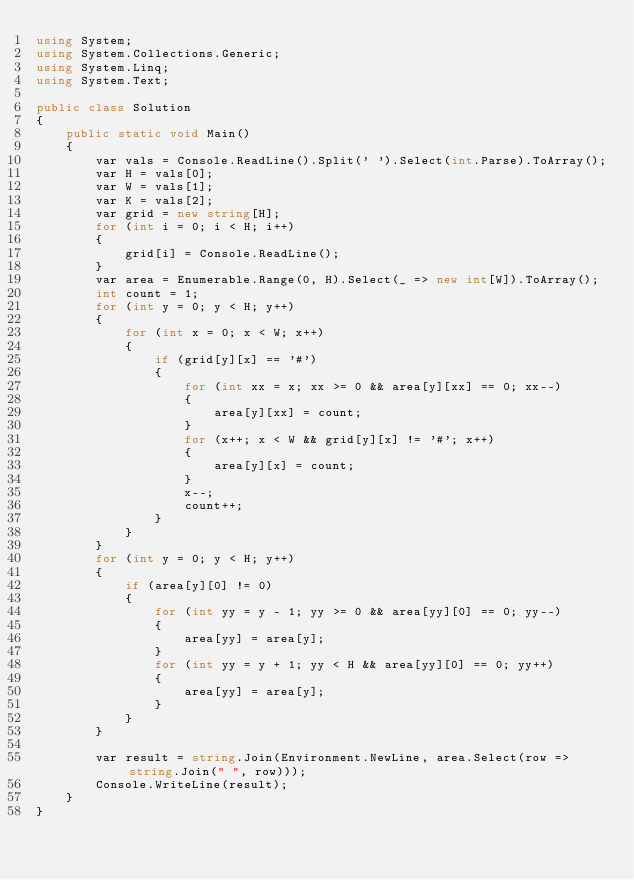Convert code to text. <code><loc_0><loc_0><loc_500><loc_500><_C#_>using System;
using System.Collections.Generic;
using System.Linq;
using System.Text;

public class Solution
{
    public static void Main()
    {
        var vals = Console.ReadLine().Split(' ').Select(int.Parse).ToArray();
        var H = vals[0];
        var W = vals[1];
        var K = vals[2];
        var grid = new string[H];
        for (int i = 0; i < H; i++)
        {
            grid[i] = Console.ReadLine();
        }
        var area = Enumerable.Range(0, H).Select(_ => new int[W]).ToArray();
        int count = 1;
        for (int y = 0; y < H; y++)
        {
            for (int x = 0; x < W; x++)
            {
                if (grid[y][x] == '#')
                {
                    for (int xx = x; xx >= 0 && area[y][xx] == 0; xx--)
                    {
                        area[y][xx] = count;
                    }
                    for (x++; x < W && grid[y][x] != '#'; x++)
                    {
                        area[y][x] = count;
                    }
                    x--;
                    count++;
                }
            }
        }
        for (int y = 0; y < H; y++)
        {
            if (area[y][0] != 0)
            {
                for (int yy = y - 1; yy >= 0 && area[yy][0] == 0; yy--)
                {
                    area[yy] = area[y];
                }
                for (int yy = y + 1; yy < H && area[yy][0] == 0; yy++)
                {
                    area[yy] = area[y];
                }
            }
        }

        var result = string.Join(Environment.NewLine, area.Select(row => string.Join(" ", row)));
        Console.WriteLine(result);
    }
}</code> 